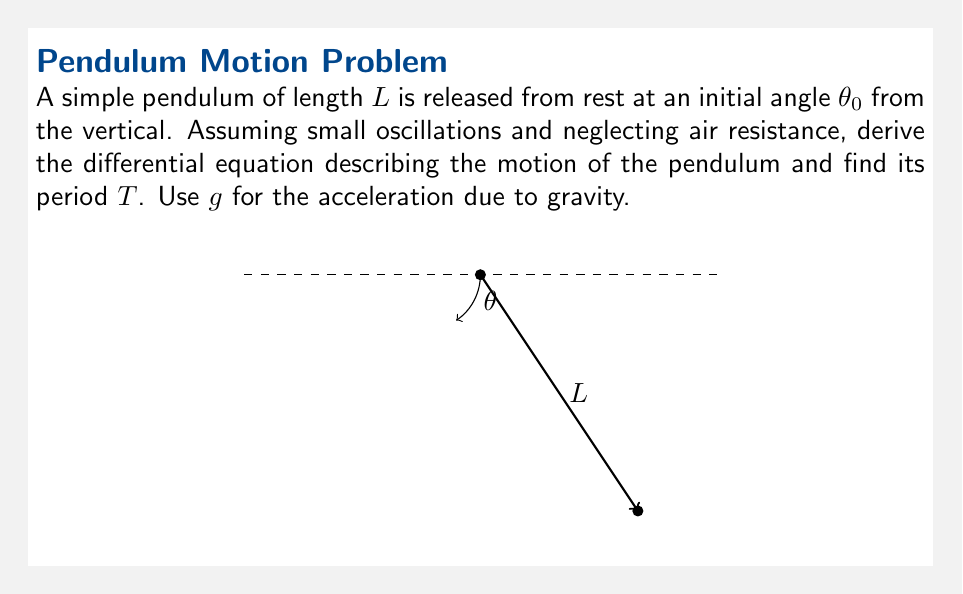Provide a solution to this math problem. Let's approach this step-by-step:

1) For small oscillations, we can approximate $\sin \theta \approx \theta$ (in radians).

2) The tangential acceleration of the pendulum bob is $L\frac{d^2\theta}{dt^2}$.

3) The restoring force is $-mg\sin \theta$, where $m$ is the mass of the bob.

4) Applying Newton's second law:

   $-mg\sin \theta = mL\frac{d^2\theta}{dt^2}$

5) Simplify by dividing both sides by $mL$:

   $\frac{d^2\theta}{dt^2} + \frac{g}{L}\sin \theta = 0$

6) For small oscillations, we can use our approximation $\sin \theta \approx \theta$:

   $\frac{d^2\theta}{dt^2} + \frac{g}{L}\theta = 0$

7) This is the differential equation describing the motion of the pendulum for small oscillations.

8) The general solution to this equation is:

   $\theta(t) = A\cos(\omega t) + B\sin(\omega t)$

   where $\omega = \sqrt{\frac{g}{L}}$

9) The period $T$ is related to $\omega$ by $T = \frac{2\pi}{\omega}$

10) Therefore, the period is:

    $T = 2\pi\sqrt{\frac{L}{g}}$

This result, known as the simple pendulum formula, is independent of the initial angle $\theta_0$ (for small oscillations) and the mass $m$ of the bob.
Answer: $T = 2\pi\sqrt{\frac{L}{g}}$ 